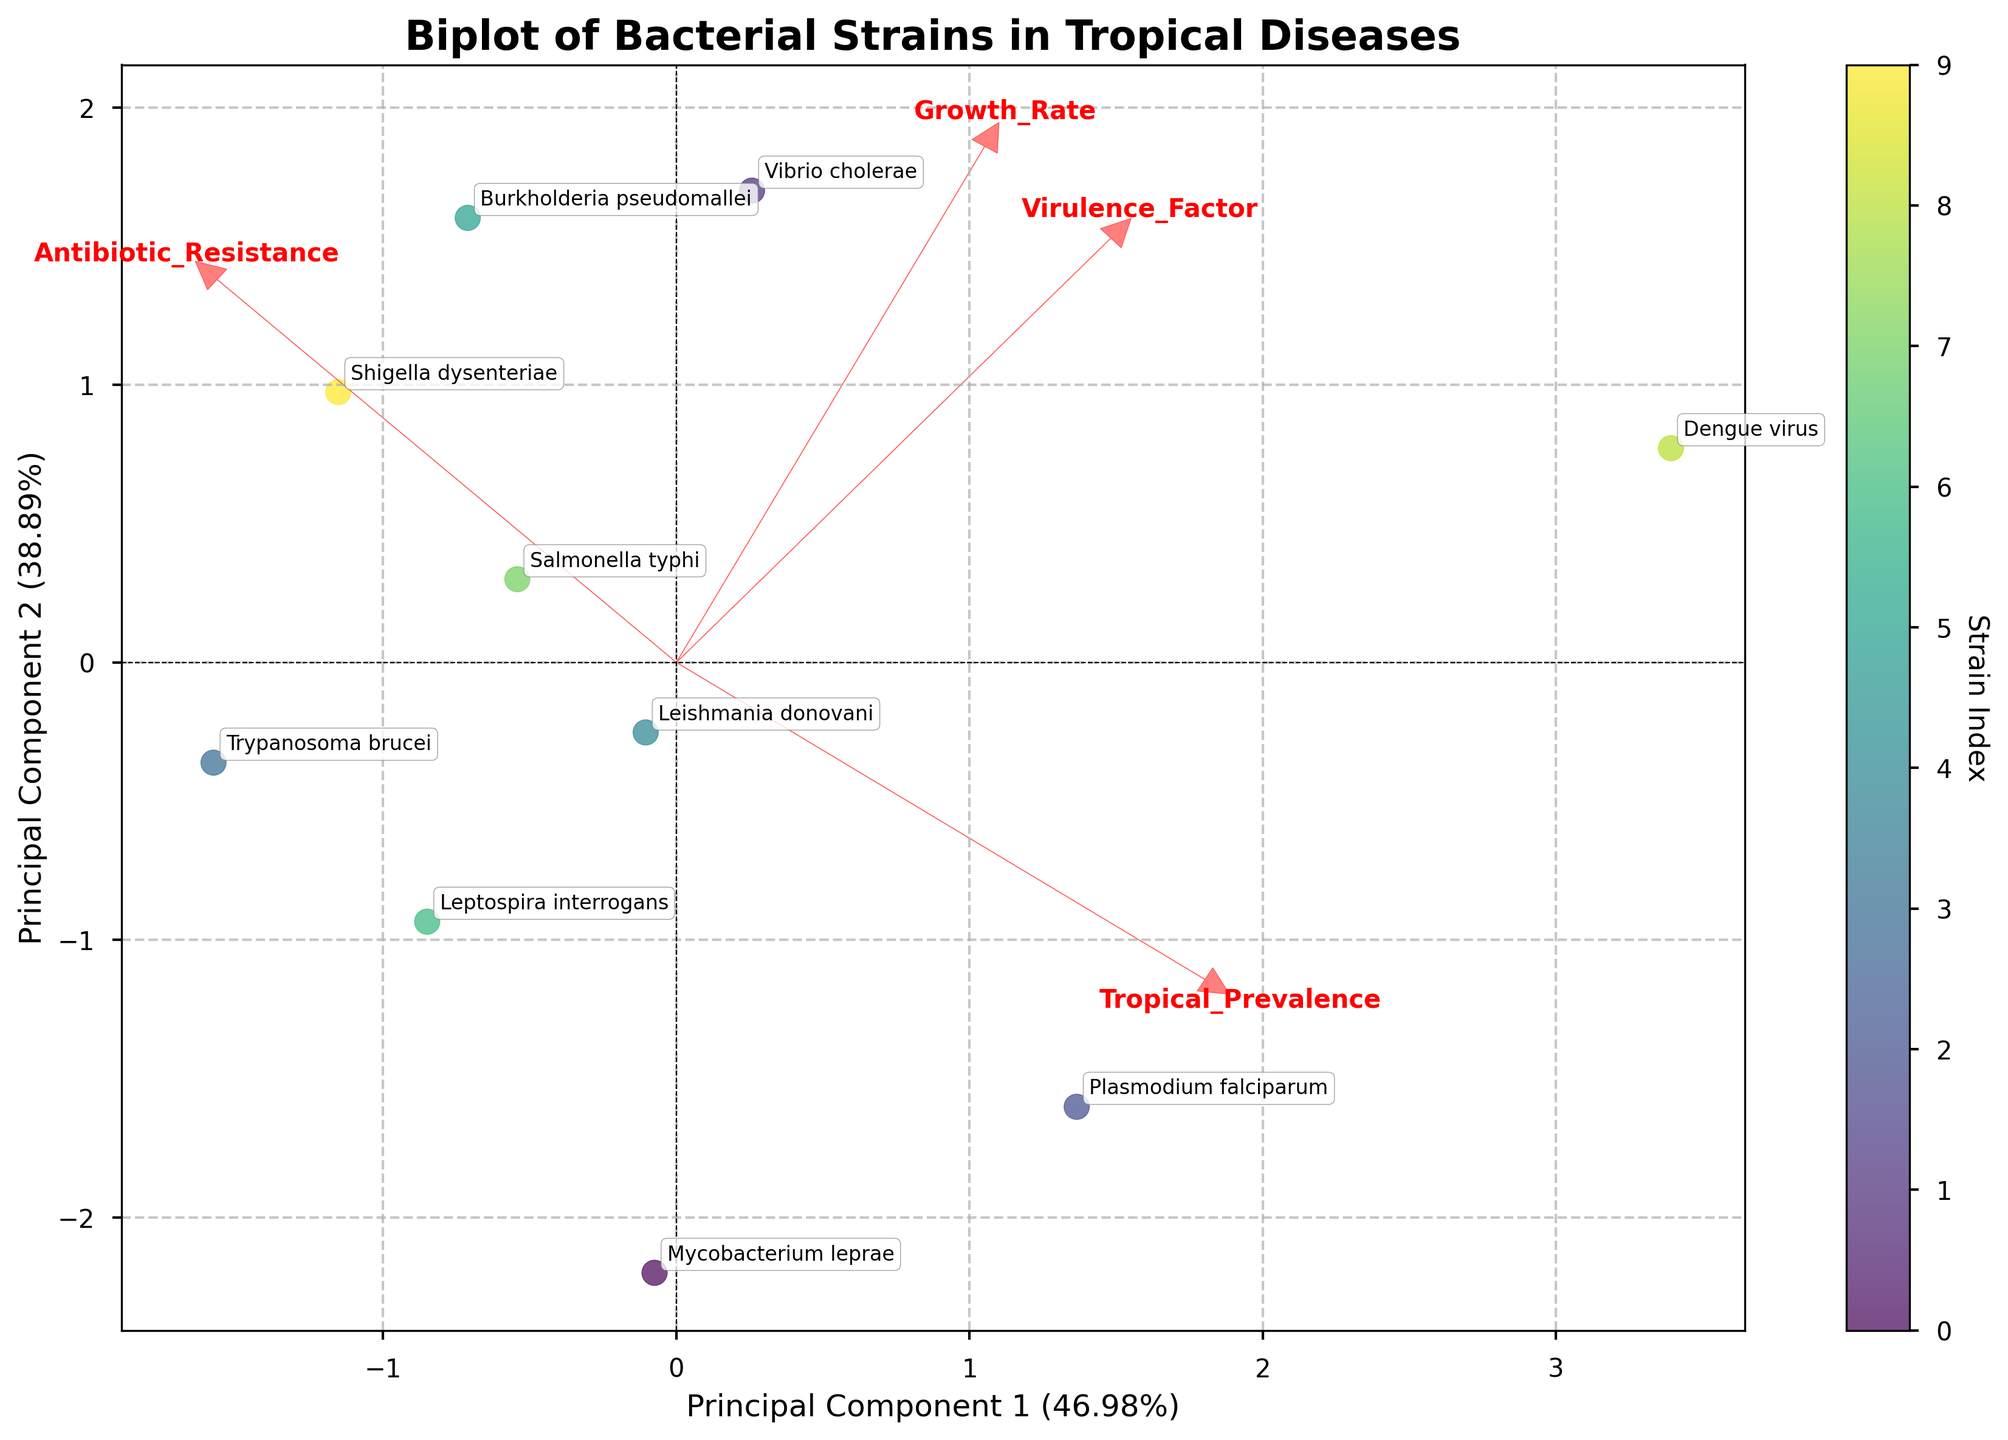What does the title of the biplot state? The title of the plot is typically found at the top of the figure. It provides an overview of the main subject of the visualization. In this case, the title explicitly mentions the type of data analyzed and the context.
Answer: Biplot of Bacterial Strains in Tropical Diseases Which principal component explains more variance in the data? To find this, look at the labels on the x and y axes. Each label's percentage indicates the variance explained by that principal component. The one with a higher percentage indicates it explains more variance.
Answer: Principal Component 1 How many bacterial strains are shown in the biplot? This can be determined by counting the individual points or labels on the plot. Each label corresponds to a unique bacterial strain.
Answer: 10 Which strain has the highest growth rate according to the biplot? Growth rate is one of the original features whose direction can be traced by looking at the arrows on the plot. The strain closest to the arrow representing high growth rate would have the highest growth rate.
Answer: Dengue virus Which strain has the highest value on Principal Component 1? Principal Component 1 is represented on the x-axis. The strain with the highest value is the one farthest to the right along this axis.
Answer: Vibrio cholerae Which strain has the highest value on Principal Component 2? Principal Component 2 is represented on the y-axis. The strain with the highest value is the one farthest up along this axis.
Answer: Dengue virus Are there any strains that appear close to each other on the biplot? If so, name them. This can be observed by looking for clusters or pairs of data points that are positioned close to each other in the plot. Closer points indicate similarities based on the principal components.
Answer: Leptospira interrogans and Trypanosoma brucei Does the biplot indicate a strong correlation between any of the original features? The strength of the relationship between the original features can be inferred by looking at the direction and length of the arrows. Arrows that are close to each other in direction indicate a strong correlation.
Answer: Antibiotic_Resistance and Virulence_Factor Which strain is closest to the origin of the biplot? The origin of the biplot is the point where x=0 and y=0. The strain closest to this point indicates it is not extreme in terms of the principal components.
Answer: Plasmodium falciparum What are the principal components mainly influenced by based on the arrows' directions in the biplot? The directions of the arrows show which original features have the most weight. Principal components represent combinations of these features. By looking at the lengths and directions of the arrows, we can infer the influence. For example, an arrow pointing in a certain direction shows the feature has a high weight in that principal component.
Answer: Antibiotic_Resistance and Growth_Rate 